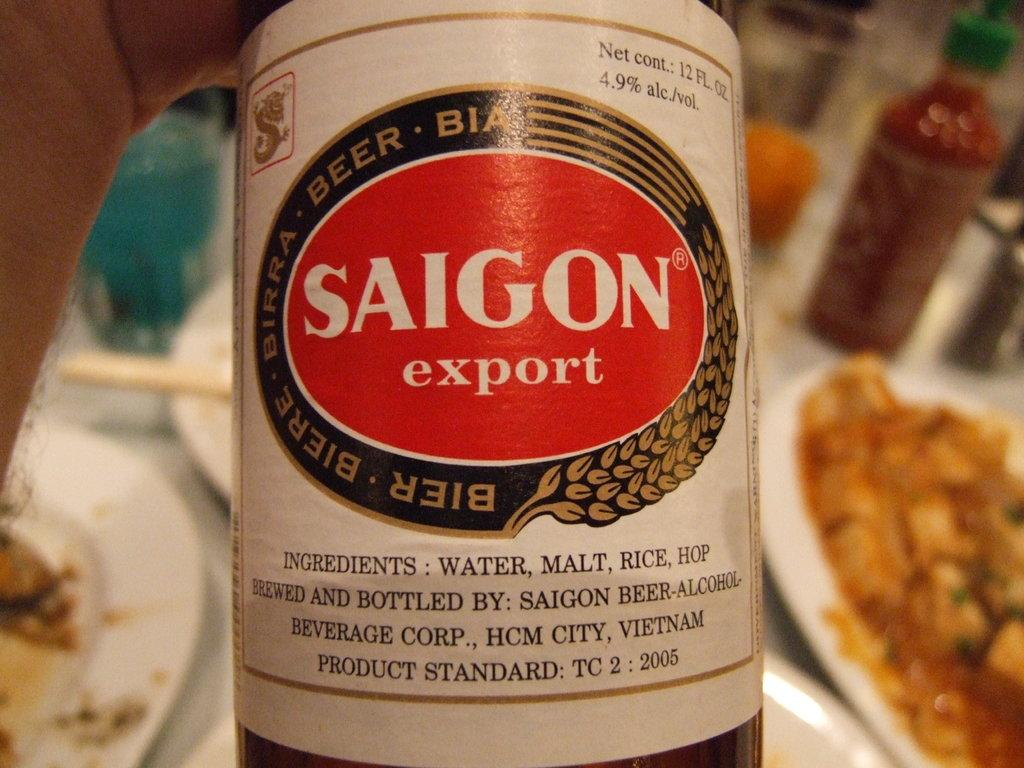<image>
Write a terse but informative summary of the picture. Saigon beer which has the ingredients of water, malt, rice, and hops. 